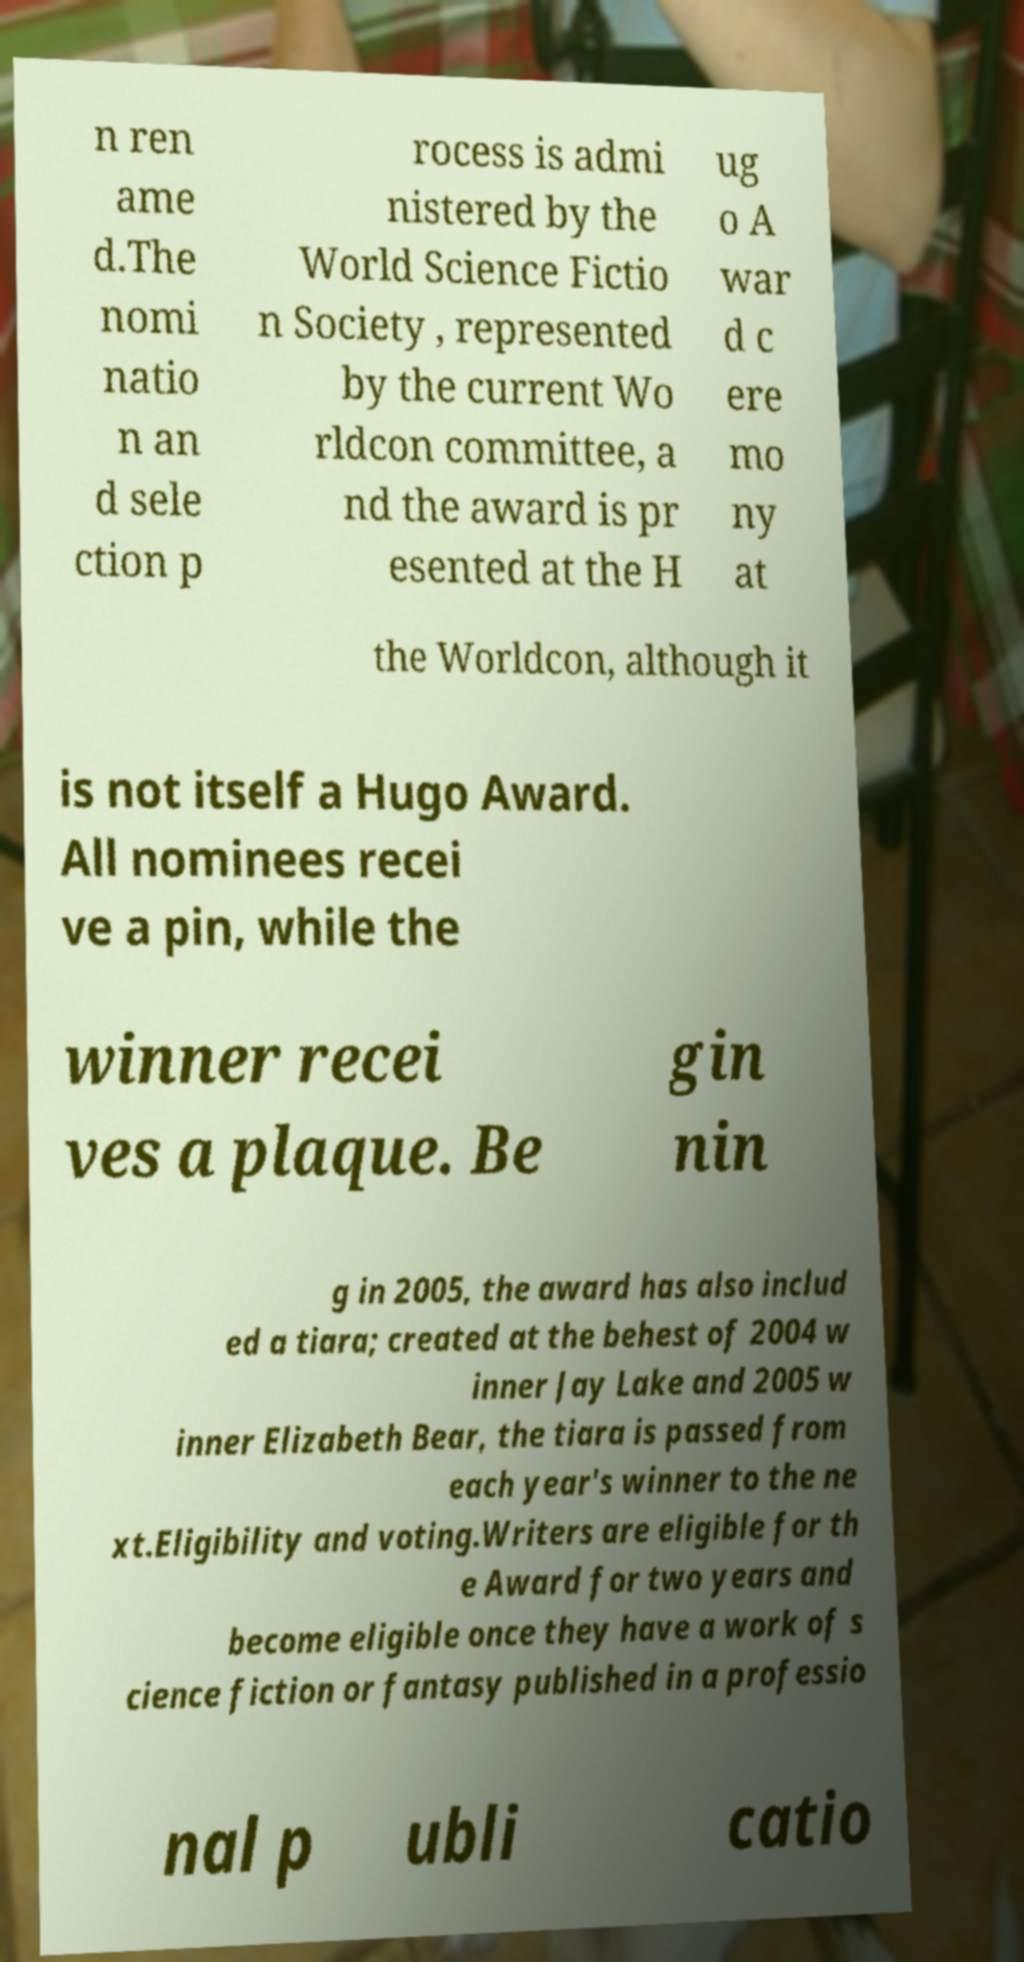For documentation purposes, I need the text within this image transcribed. Could you provide that? n ren ame d.The nomi natio n an d sele ction p rocess is admi nistered by the World Science Fictio n Society , represented by the current Wo rldcon committee, a nd the award is pr esented at the H ug o A war d c ere mo ny at the Worldcon, although it is not itself a Hugo Award. All nominees recei ve a pin, while the winner recei ves a plaque. Be gin nin g in 2005, the award has also includ ed a tiara; created at the behest of 2004 w inner Jay Lake and 2005 w inner Elizabeth Bear, the tiara is passed from each year's winner to the ne xt.Eligibility and voting.Writers are eligible for th e Award for two years and become eligible once they have a work of s cience fiction or fantasy published in a professio nal p ubli catio 